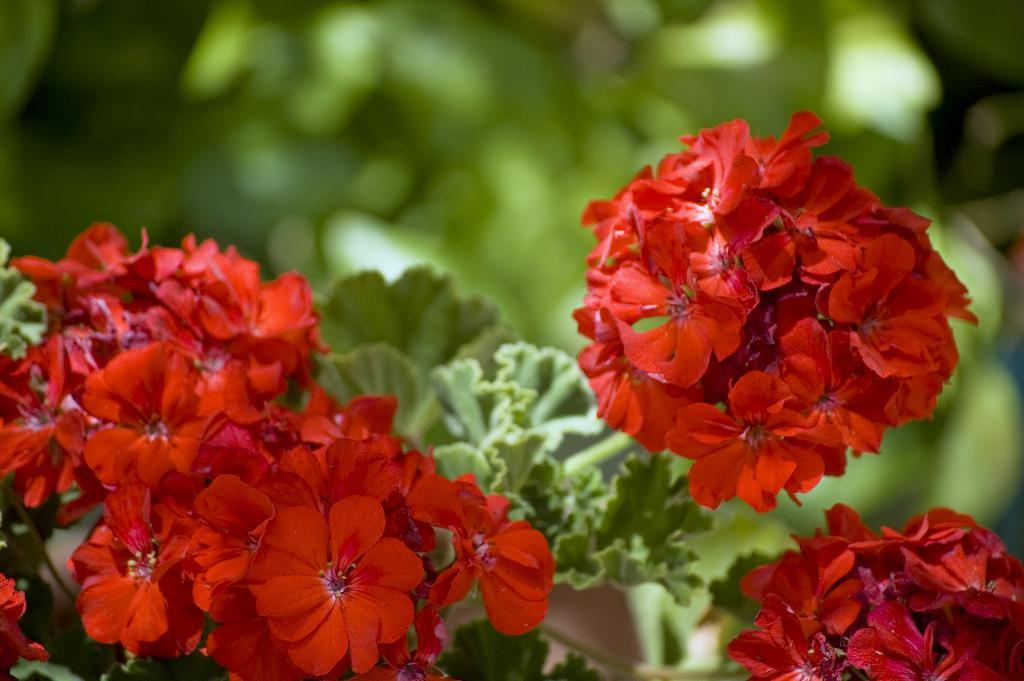What type of flora can be seen in the image? There are flowers in the image. Are there any other plants visible in the image? Yes, there are plants behind the flowers. Can you describe the background of the image? The background of the image is blurred. What type of hole can be seen in the image? There is no hole present in the image. 